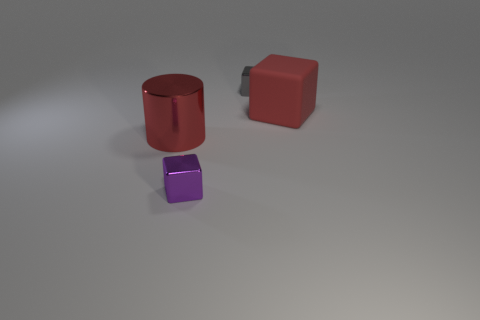Subtract all red matte cubes. How many cubes are left? 2 Subtract 1 blocks. How many blocks are left? 2 Add 1 small gray things. How many objects exist? 5 Add 1 big gray metallic things. How many big gray metallic things exist? 1 Subtract 1 gray blocks. How many objects are left? 3 Subtract all cylinders. How many objects are left? 3 Subtract all purple cubes. Subtract all brown cylinders. How many cubes are left? 2 Subtract all gray spheres. How many gray cubes are left? 1 Subtract all large metal cylinders. Subtract all gray metallic blocks. How many objects are left? 2 Add 3 purple metallic objects. How many purple metallic objects are left? 4 